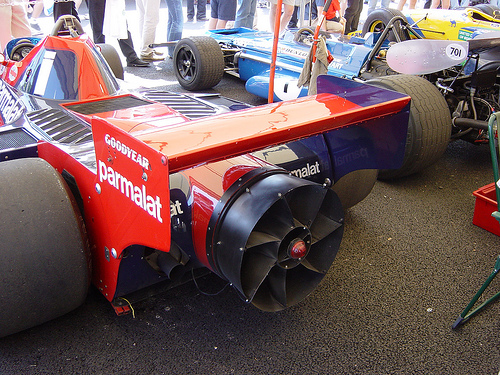<image>
Is the people on the car? No. The people is not positioned on the car. They may be near each other, but the people is not supported by or resting on top of the car. 